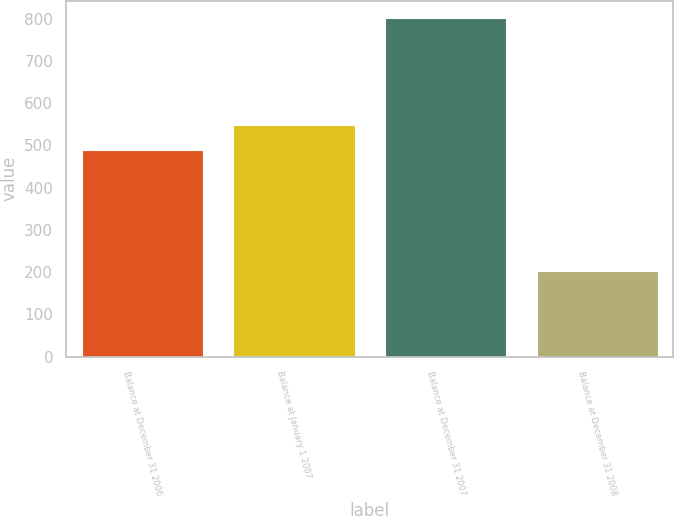Convert chart to OTSL. <chart><loc_0><loc_0><loc_500><loc_500><bar_chart><fcel>Balance at December 31 2006<fcel>Balance at January 1 2007<fcel>Balance at December 31 2007<fcel>Balance at December 31 2008<nl><fcel>489<fcel>549<fcel>802<fcel>202<nl></chart> 